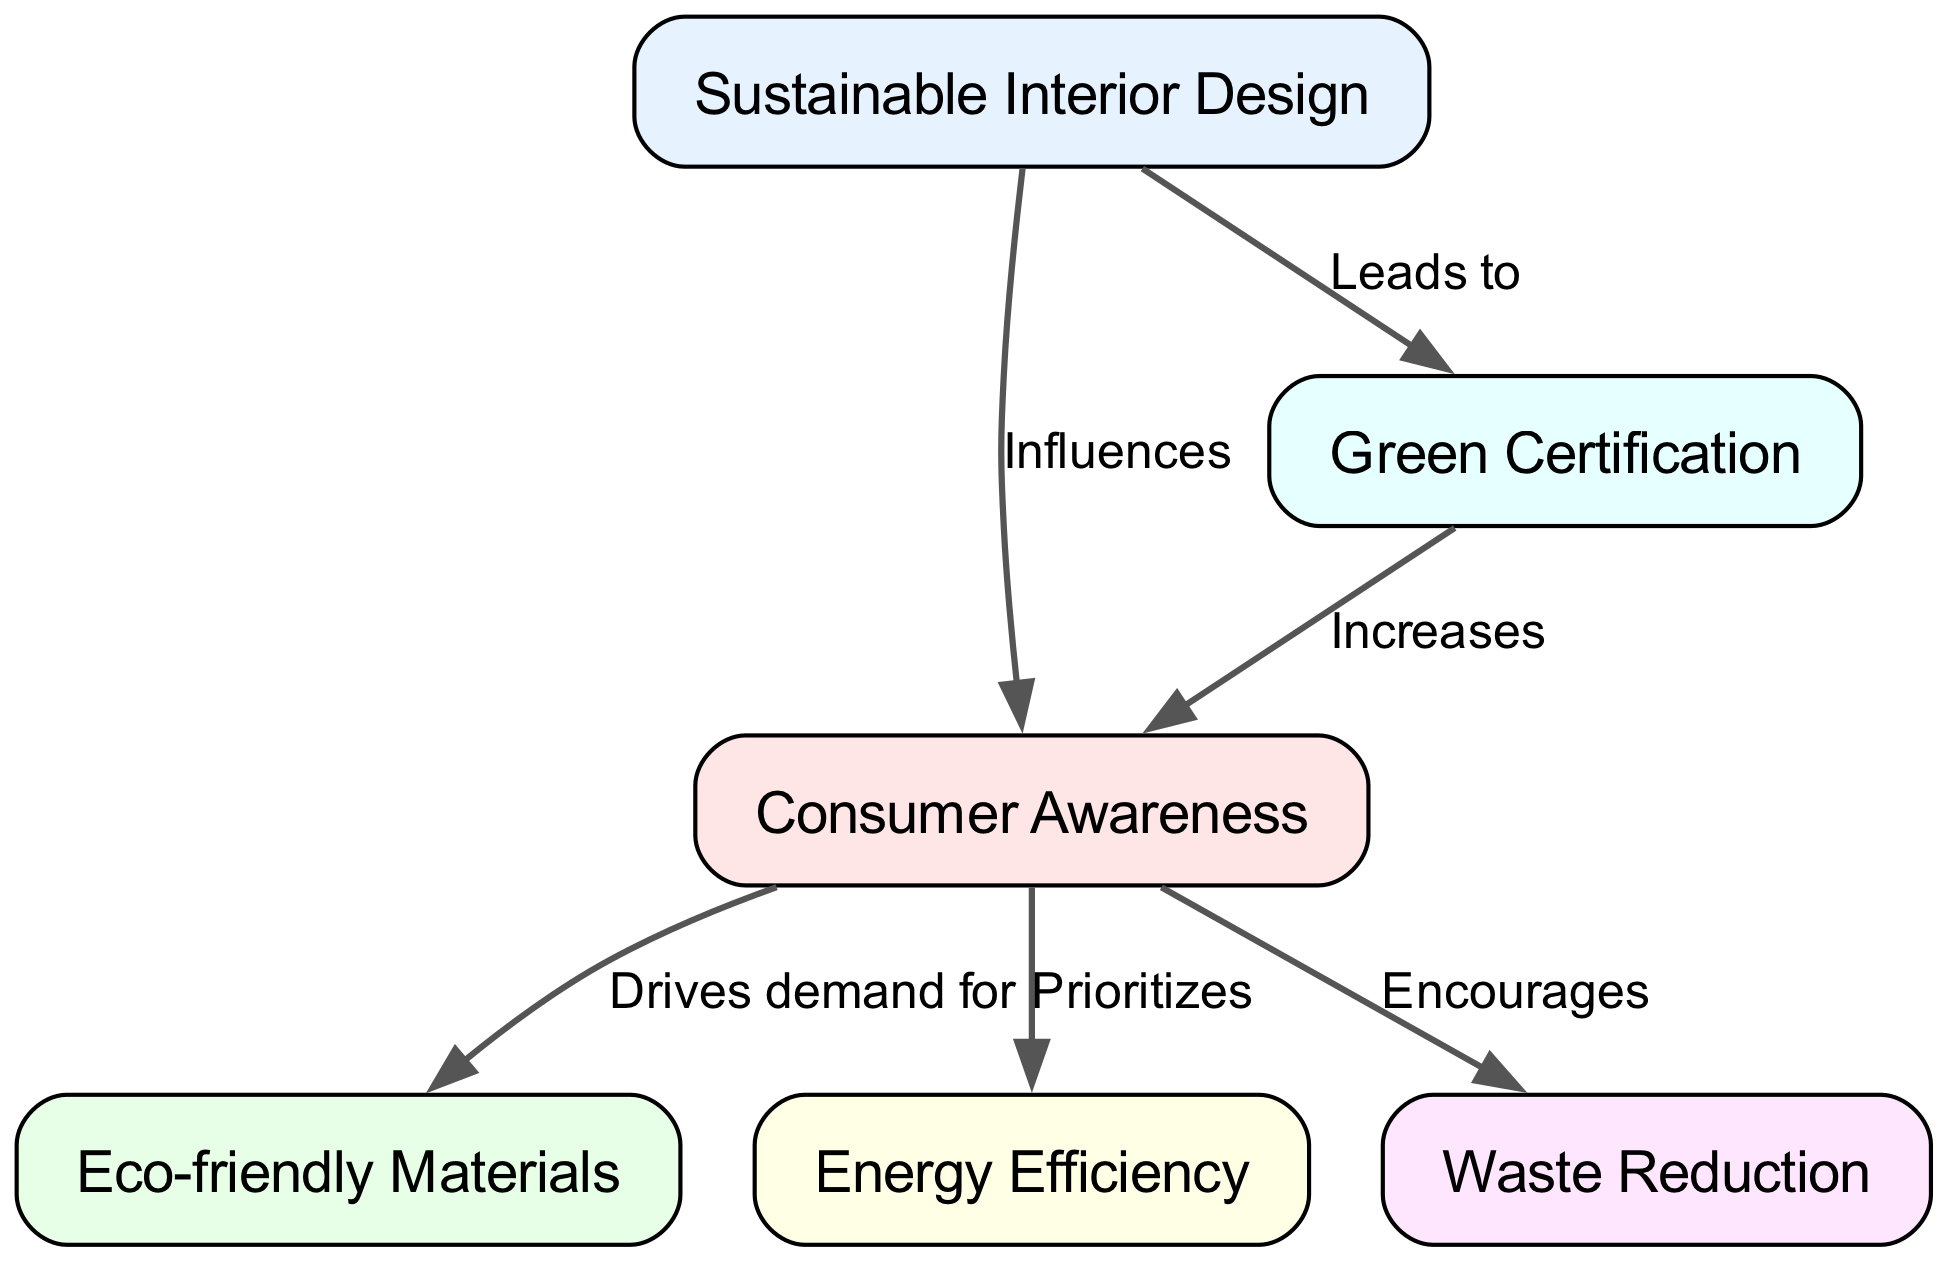What is the main concept at the center of the diagram? The main concept, which is the central node, is "Sustainable Interior Design," indicating that all connections in the diagram relate back to this key topic.
Answer: Sustainable Interior Design How many nodes are represented in the diagram? By counting all the distinct points (or nodes) shown in the diagram, it can be determined that there are a total of six nodes.
Answer: 6 What does "Consumer Awareness" influence in the diagram? The diagram indicates that "Consumer Awareness" influences "Sustainable Interior Design," suggesting that awareness affects how this design approach is perceived and adopted.
Answer: Sustainable Interior Design Which node is directly connected to "Green Certification"? "Green Certification" leads to "Consumer Awareness," meaning this certification is a factor that increases awareness among consumers regarding sustainable practices.
Answer: Consumer Awareness What relationship does "Eco-friendly Materials" have with "Consumer Awareness"? The diagram shows that "Consumer Awareness" drives demand for "Eco-friendly Materials," indicating that increased awareness leads to a higher interest in using these materials.
Answer: Drives demand for What is the impact of "Green Certification" on consumer behavior? According to the diagram, "Green Certification" increases "Consumer Awareness," suggesting that this certification plays a crucial role in educating consumers about sustainable options.
Answer: Increases How does "Waste Reduction" relate to "Consumer Awareness"? The diagram states that "Consumer Awareness" encourages "Waste Reduction," implying that when consumers are aware of sustainability, they are more likely to take steps to minimize waste.
Answer: Encourages What does "Sustainable Interior Design" lead to? The diagram indicates that "Sustainable Interior Design" leads to "Green Certification," suggesting that adopting sustainable practices often results in obtaining such certifications.
Answer: Green Certification Which two nodes are directly connected with an influence relationship? "Sustainable Interior Design" and "Consumer Awareness" have a direct influence relationship, illustrating how the former affects the attitudes and understanding of consumers.
Answer: Influences 